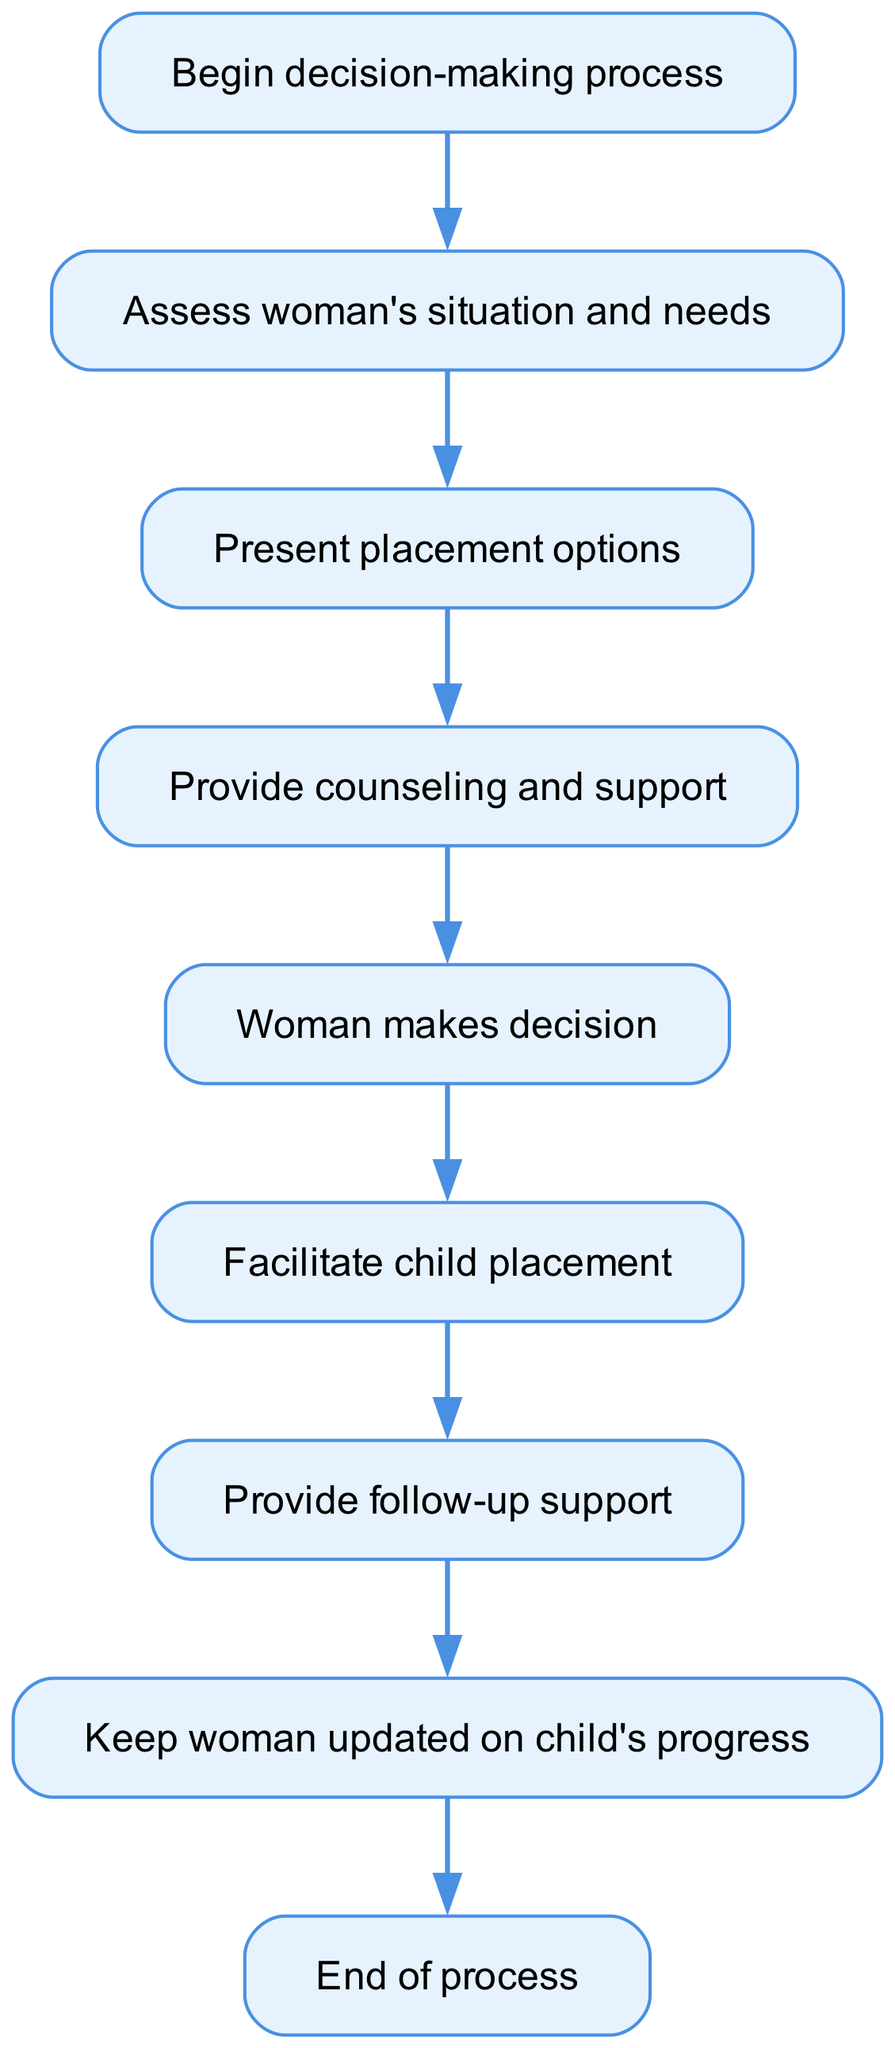What's the first step in the decision-making process? The first step is represented by the node labeled "Begin decision-making process". It is the initial point in the flowchart from which the process starts.
Answer: Begin decision-making process How many nodes are there in the diagram? By counting the nodes listed in the data, there are 9 distinct nodes present in the diagram, each representing a step in the process.
Answer: 9 What step follows the assessment of a woman's situation and needs? After assessing the woman's situation and needs, the next node in the sequence is "Present placement options", indicating that options are shown afterward.
Answer: Present placement options What is the last step of the process? The last step is indicated by the node "End of process", which signifies the conclusion of the decision-making flow.
Answer: End of process Which step occurs directly after providing counseling and support? Directly after the "Provide counseling and support" step, the next step is where the "Woman makes decision", showing the progression of the workflow.
Answer: Woman makes decision What are the steps from decision to follow-up? The steps from "Woman makes decision" to "Provide follow-up support" are sequentially connected, representing the transition between making a decision on placement and the subsequent action of follow-up.
Answer: Provide follow-up support What type of process does this flowchart represent? The flowchart illustrates a decision-making process specifically focused on child placement options, guiding through assessments and support.
Answer: Decision-making process Which two steps are directly connected by an edge? The step "Assess woman's situation and needs" directly connects to "Present placement options" via an edge, indicating a direct progression in the flowchart.
Answer: Present placement options How many edges are in the flowchart? By counting the edges that connect the nodes in the data, there are 8 edges in total, which show the relationships and flow between the steps.
Answer: 8 